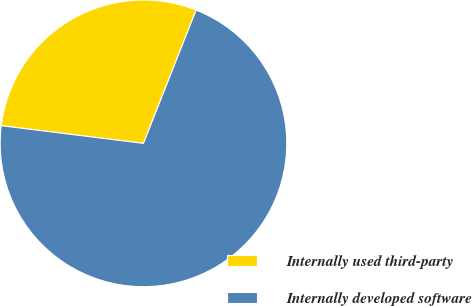Convert chart. <chart><loc_0><loc_0><loc_500><loc_500><pie_chart><fcel>Internally used third-party<fcel>Internally developed software<nl><fcel>29.02%<fcel>70.98%<nl></chart> 